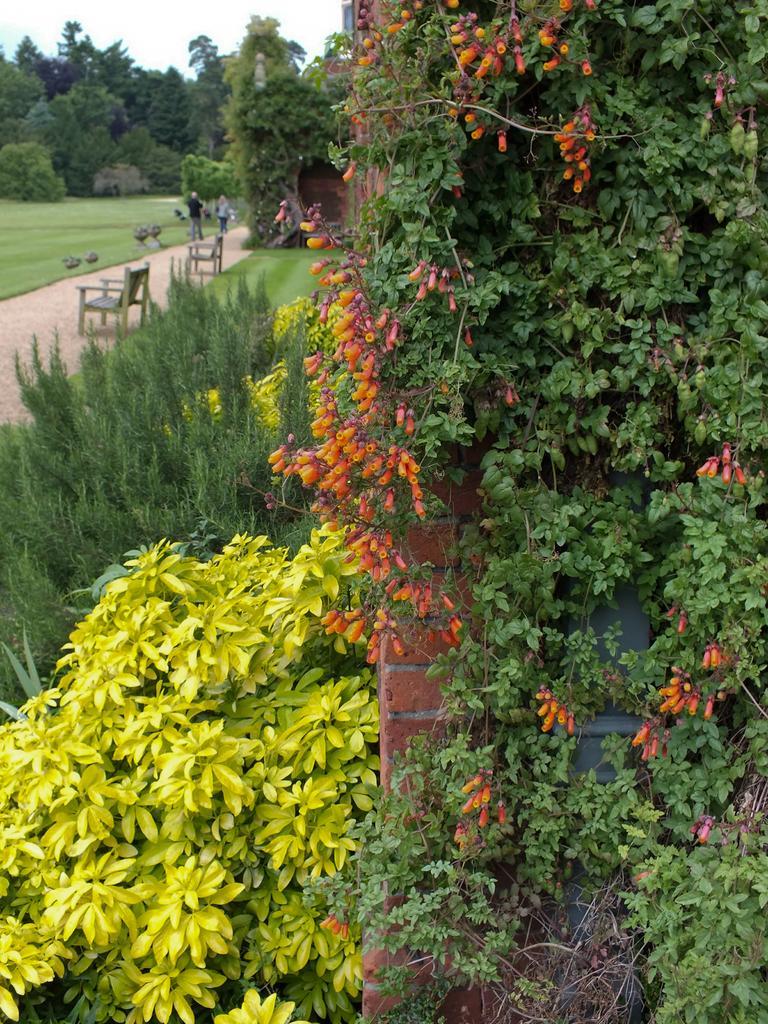Could you give a brief overview of what you see in this image? These are the trees and bushes. I can see two benches. Here is a person standing. This is the grass. I can see the flowers to a tree. This looks like a wall. 